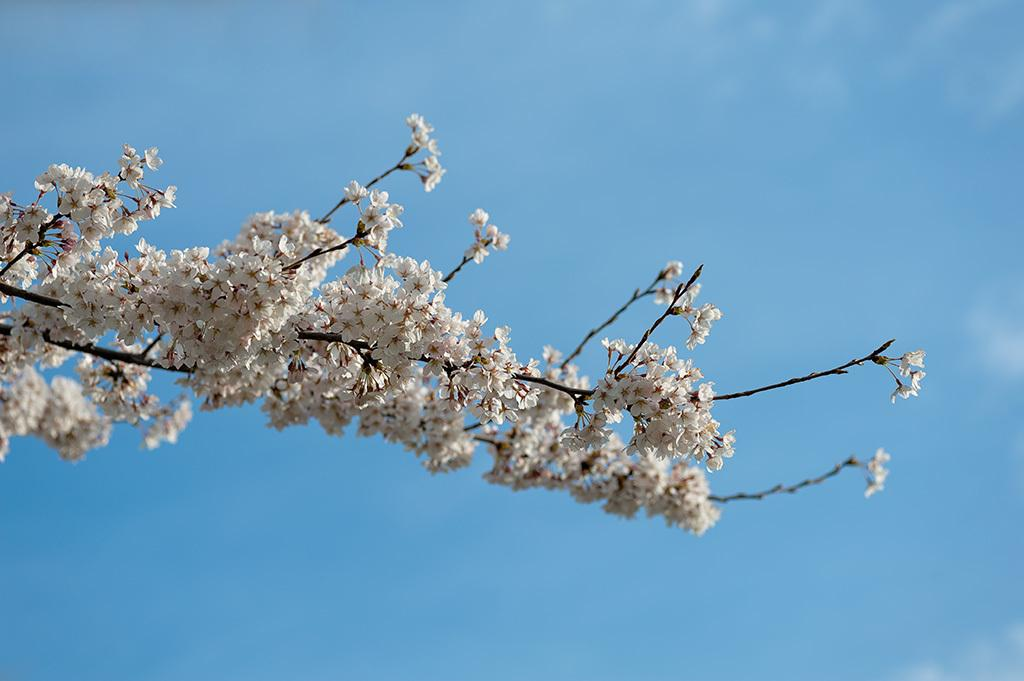What is the main subject of the image? There is a bunch of flowers in the image. What color is the background of the image? The background of the image is blue. What type of lock is used to secure the flowers in the image? There is no lock present in the image; the flowers are not secured. What type of drink is being served with the flowers in the image? There is no drink present in the image; it only features a bunch of flowers. 